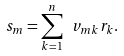<formula> <loc_0><loc_0><loc_500><loc_500>s _ { m } = \sum _ { k = 1 } ^ { n } \ v _ { m k } r _ { k } .</formula> 